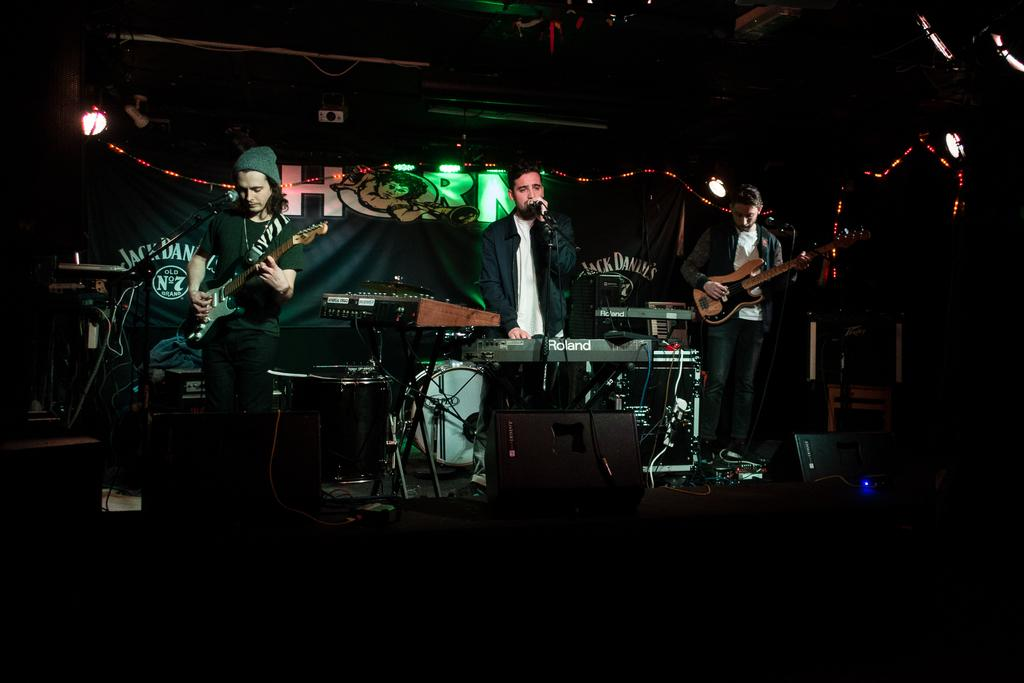How many people are in the image? There are three people in the image. What are the people doing in the image? The people are standing near music players. What can be seen in the background of the image? There is a banner, lights, and a projector in the background of the image. What type of guide is being used to rake the sidewalk in the image? There is no guide or rake present in the image, and the sidewalk is not mentioned. 